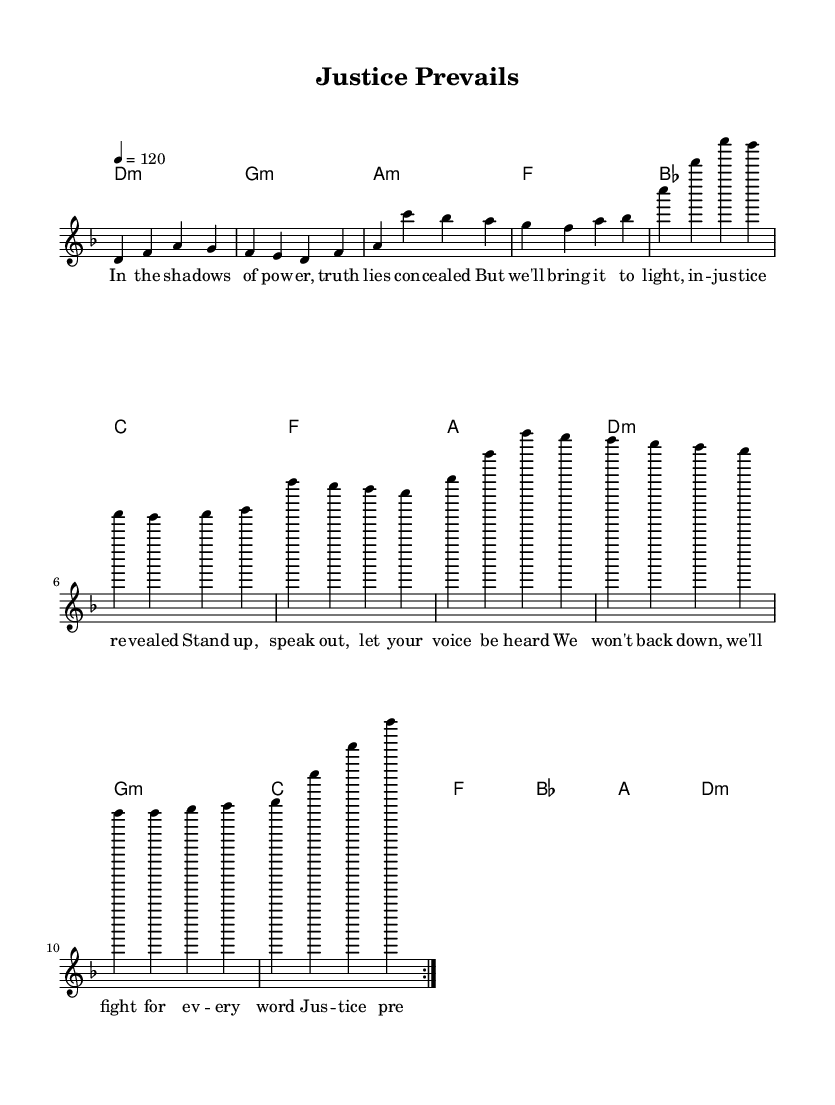What is the key signature of this music? The key signature is D minor, indicated by the presence of one flat (B flat) on the staff.
Answer: D minor What is the time signature of this music? The time signature is 4/4, which is shown at the beginning of the score and indicates four beats per measure.
Answer: 4/4 What is the tempo marking for this piece? The tempo marking is also given at the beginning with the indication "4 = 120", which tells the performer to play at a speed of 120 beats per minute.
Answer: 120 How many measures are there in the melody before the repeat? By counting each measure in the melody section, we find that there are 8 measures before the repeat indication.
Answer: 8 What is the main theme of the lyrics? The lyrics discuss themes of justice, standing up against power, and fighting for truth, which is common in K-Pop songs that reflect societal issues.
Answer: Justice How do the lyrics reinforce the message of the song? The lyrics emphasize action, such as "stand up" and "speak out," and highlight the importance of perseverance against corruption, showcasing a powerful call to activism.
Answer: Perseverance What type of chords are used primarily in the harmonies? The chords are primarily minor and major, giving the piece a mix of tension and resolution, which enhances the emotional delivery typical in K-Pop.
Answer: Minor and Major 